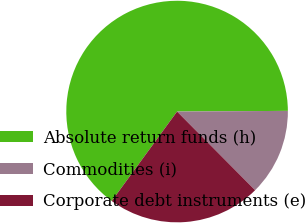Convert chart to OTSL. <chart><loc_0><loc_0><loc_500><loc_500><pie_chart><fcel>Absolute return funds (h)<fcel>Commodities (i)<fcel>Corporate debt instruments (e)<nl><fcel>64.86%<fcel>12.66%<fcel>22.48%<nl></chart> 